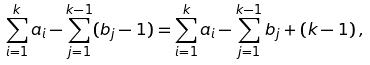<formula> <loc_0><loc_0><loc_500><loc_500>\sum _ { i = 1 } ^ { k } a _ { i } - \sum _ { j = 1 } ^ { k - 1 } ( b _ { j } - 1 ) = \sum _ { i = 1 } ^ { k } a _ { i } - \sum _ { j = 1 } ^ { k - 1 } b _ { j } + ( k - 1 ) \, ,</formula> 